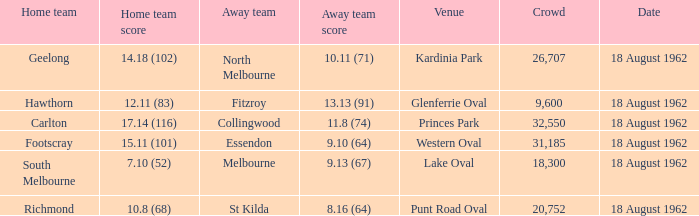What was the home team that scored 10.8 (68)? Richmond. 